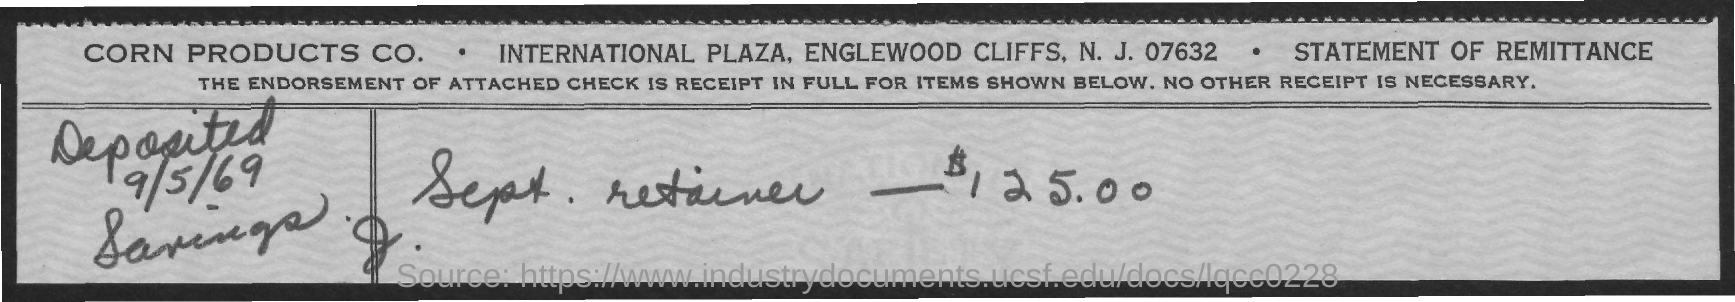List a handful of essential elements in this visual. The amount is 125.00. The date on the document is September 5, 1969. 